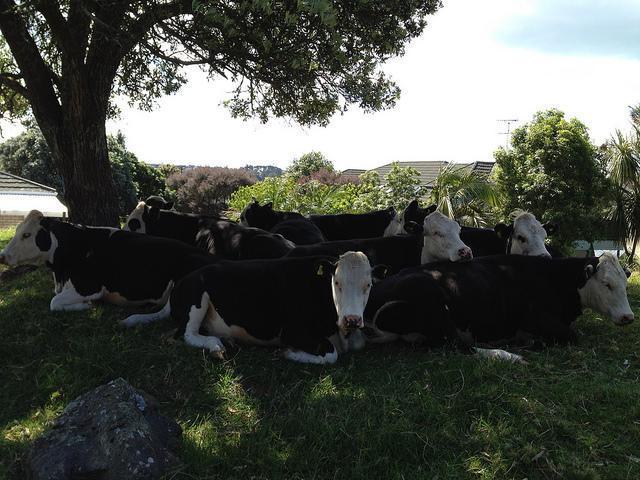How many cows are there?
Give a very brief answer. 7. 